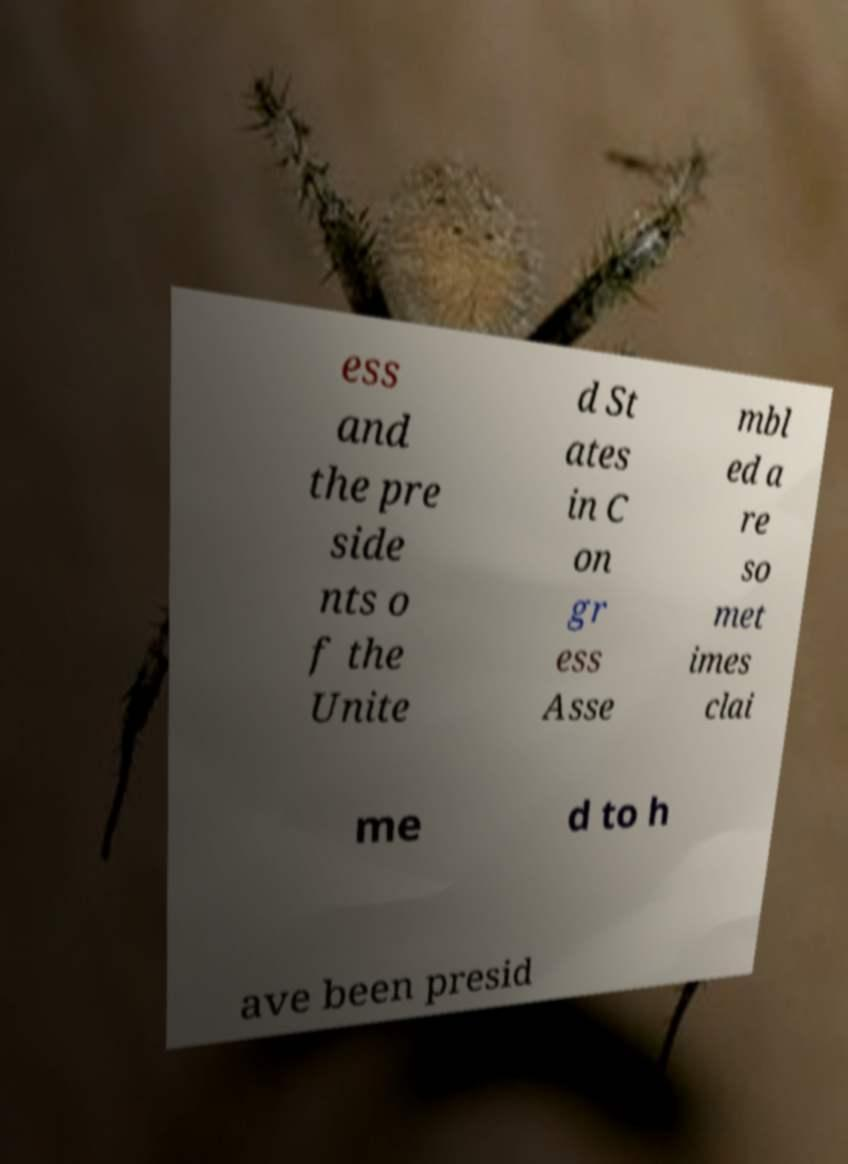I need the written content from this picture converted into text. Can you do that? ess and the pre side nts o f the Unite d St ates in C on gr ess Asse mbl ed a re so met imes clai me d to h ave been presid 